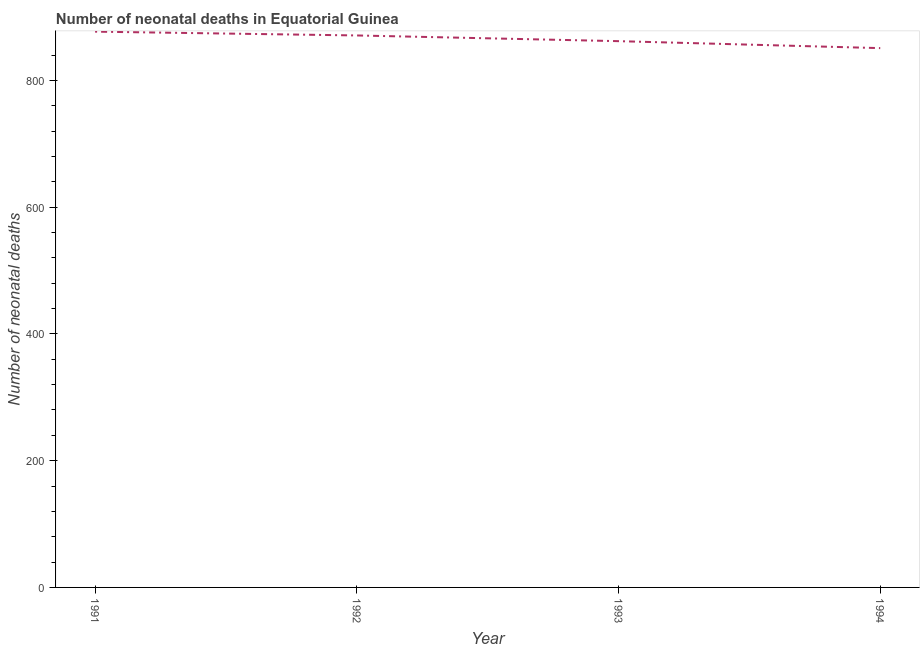What is the number of neonatal deaths in 1993?
Keep it short and to the point. 862. Across all years, what is the maximum number of neonatal deaths?
Offer a terse response. 877. Across all years, what is the minimum number of neonatal deaths?
Keep it short and to the point. 851. In which year was the number of neonatal deaths maximum?
Your response must be concise. 1991. What is the sum of the number of neonatal deaths?
Your answer should be very brief. 3461. What is the difference between the number of neonatal deaths in 1991 and 1993?
Your answer should be compact. 15. What is the average number of neonatal deaths per year?
Keep it short and to the point. 865.25. What is the median number of neonatal deaths?
Keep it short and to the point. 866.5. Do a majority of the years between 1993 and 1992 (inclusive) have number of neonatal deaths greater than 560 ?
Keep it short and to the point. No. What is the ratio of the number of neonatal deaths in 1992 to that in 1994?
Provide a succinct answer. 1.02. Is the difference between the number of neonatal deaths in 1992 and 1994 greater than the difference between any two years?
Your answer should be compact. No. What is the difference between the highest and the second highest number of neonatal deaths?
Provide a short and direct response. 6. What is the difference between the highest and the lowest number of neonatal deaths?
Provide a short and direct response. 26. In how many years, is the number of neonatal deaths greater than the average number of neonatal deaths taken over all years?
Keep it short and to the point. 2. How many years are there in the graph?
Your answer should be compact. 4. What is the difference between two consecutive major ticks on the Y-axis?
Provide a short and direct response. 200. Are the values on the major ticks of Y-axis written in scientific E-notation?
Ensure brevity in your answer.  No. What is the title of the graph?
Your response must be concise. Number of neonatal deaths in Equatorial Guinea. What is the label or title of the X-axis?
Keep it short and to the point. Year. What is the label or title of the Y-axis?
Offer a very short reply. Number of neonatal deaths. What is the Number of neonatal deaths of 1991?
Your answer should be compact. 877. What is the Number of neonatal deaths of 1992?
Offer a terse response. 871. What is the Number of neonatal deaths of 1993?
Your response must be concise. 862. What is the Number of neonatal deaths in 1994?
Your answer should be compact. 851. What is the difference between the Number of neonatal deaths in 1991 and 1993?
Provide a succinct answer. 15. What is the difference between the Number of neonatal deaths in 1991 and 1994?
Your response must be concise. 26. What is the difference between the Number of neonatal deaths in 1992 and 1993?
Your answer should be very brief. 9. What is the ratio of the Number of neonatal deaths in 1991 to that in 1994?
Make the answer very short. 1.03. What is the ratio of the Number of neonatal deaths in 1992 to that in 1993?
Offer a very short reply. 1.01. What is the ratio of the Number of neonatal deaths in 1992 to that in 1994?
Your answer should be compact. 1.02. 